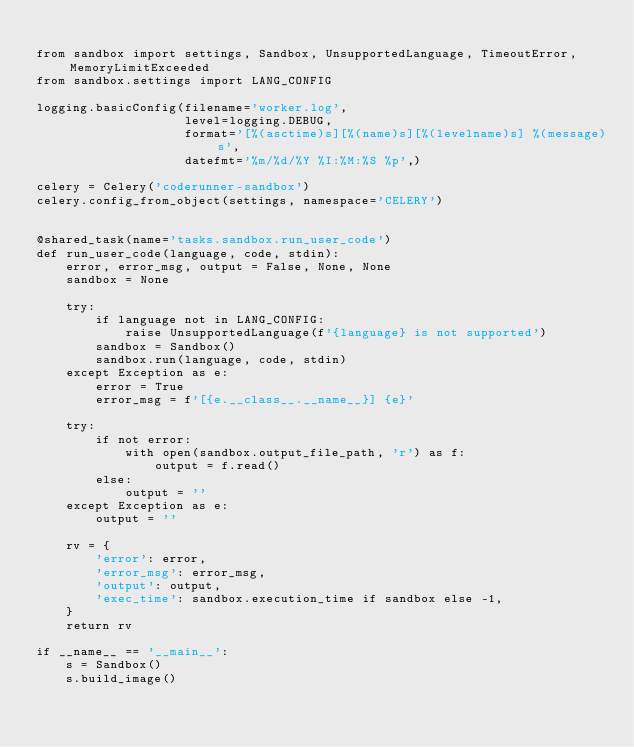Convert code to text. <code><loc_0><loc_0><loc_500><loc_500><_Python_>
from sandbox import settings, Sandbox, UnsupportedLanguage, TimeoutError, MemoryLimitExceeded
from sandbox.settings import LANG_CONFIG

logging.basicConfig(filename='worker.log',
                    level=logging.DEBUG,
                    format='[%(asctime)s][%(name)s][%(levelname)s] %(message)s',
                    datefmt='%m/%d/%Y %I:%M:%S %p',)

celery = Celery('coderunner-sandbox')
celery.config_from_object(settings, namespace='CELERY')


@shared_task(name='tasks.sandbox.run_user_code')
def run_user_code(language, code, stdin):
    error, error_msg, output = False, None, None
    sandbox = None

    try:
        if language not in LANG_CONFIG:
            raise UnsupportedLanguage(f'{language} is not supported')
        sandbox = Sandbox()
        sandbox.run(language, code, stdin)
    except Exception as e:
        error = True
        error_msg = f'[{e.__class__.__name__}] {e}'

    try:
        if not error:
            with open(sandbox.output_file_path, 'r') as f:
                output = f.read()
        else:
            output = ''
    except Exception as e:
        output = ''

    rv = {
        'error': error,
        'error_msg': error_msg,
        'output': output,
        'exec_time': sandbox.execution_time if sandbox else -1,
    }
    return rv

if __name__ == '__main__':
    s = Sandbox()
    s.build_image()</code> 